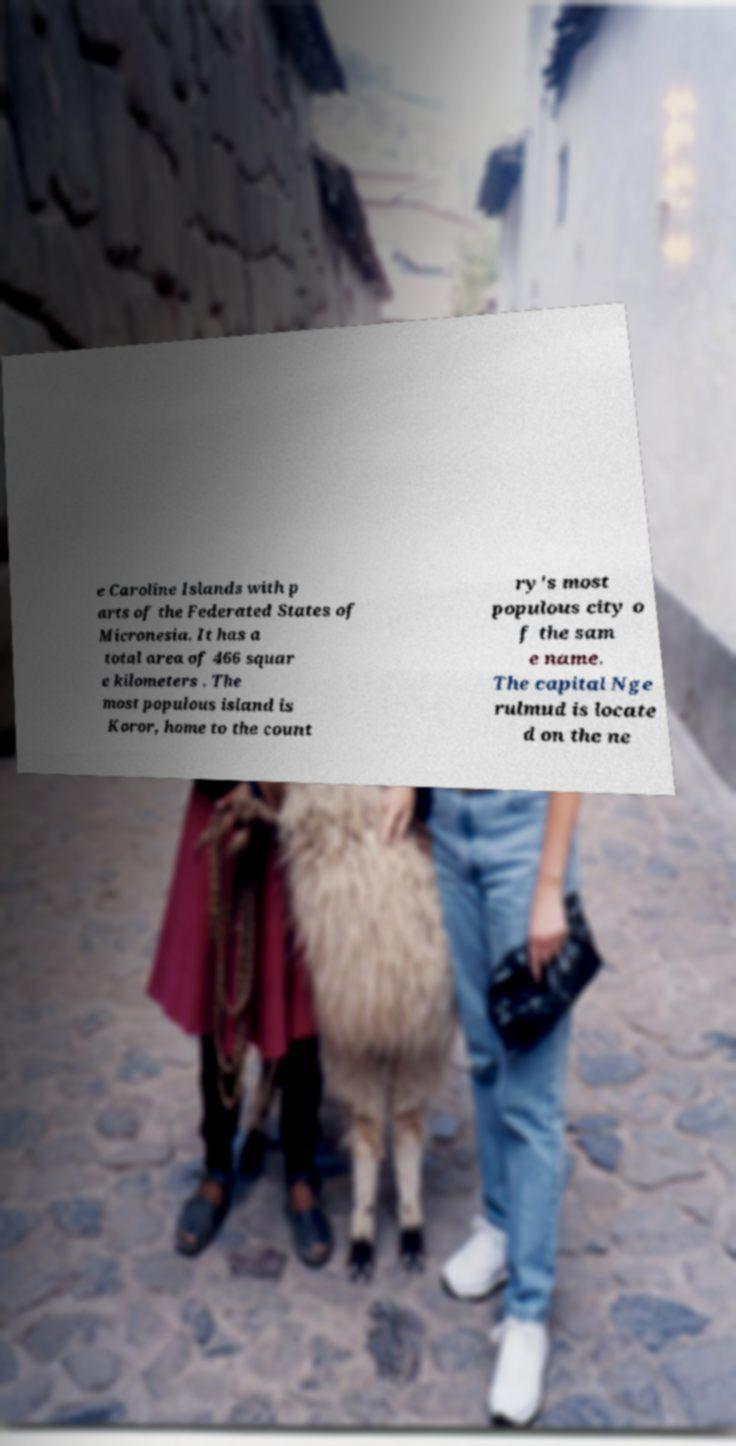I need the written content from this picture converted into text. Can you do that? e Caroline Islands with p arts of the Federated States of Micronesia. It has a total area of 466 squar e kilometers . The most populous island is Koror, home to the count ry's most populous city o f the sam e name. The capital Nge rulmud is locate d on the ne 